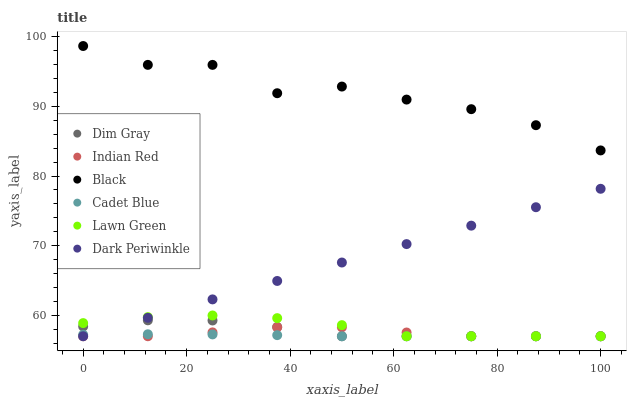Does Cadet Blue have the minimum area under the curve?
Answer yes or no. Yes. Does Black have the maximum area under the curve?
Answer yes or no. Yes. Does Dim Gray have the minimum area under the curve?
Answer yes or no. No. Does Dim Gray have the maximum area under the curve?
Answer yes or no. No. Is Dark Periwinkle the smoothest?
Answer yes or no. Yes. Is Black the roughest?
Answer yes or no. Yes. Is Cadet Blue the smoothest?
Answer yes or no. No. Is Cadet Blue the roughest?
Answer yes or no. No. Does Lawn Green have the lowest value?
Answer yes or no. Yes. Does Black have the lowest value?
Answer yes or no. No. Does Black have the highest value?
Answer yes or no. Yes. Does Dim Gray have the highest value?
Answer yes or no. No. Is Lawn Green less than Black?
Answer yes or no. Yes. Is Black greater than Lawn Green?
Answer yes or no. Yes. Does Dark Periwinkle intersect Indian Red?
Answer yes or no. Yes. Is Dark Periwinkle less than Indian Red?
Answer yes or no. No. Is Dark Periwinkle greater than Indian Red?
Answer yes or no. No. Does Lawn Green intersect Black?
Answer yes or no. No. 